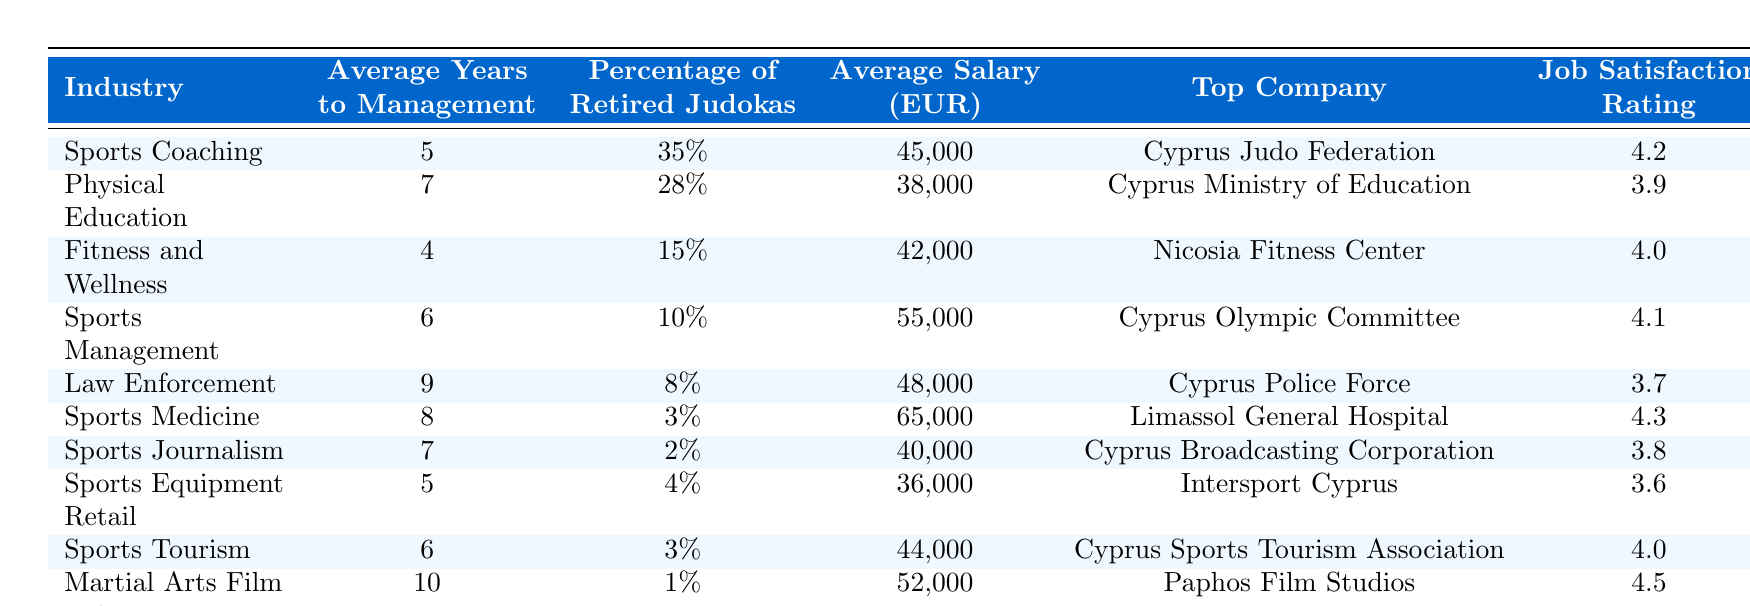What is the average salary in the Sports Medicine industry? According to the table, the average salary in the Sports Medicine industry is listed as 65,000 EUR.
Answer: 65,000 EUR What percentage of retired judokas work in Sports Management? The table states that 10% of retired judokas work in the Sports Management industry.
Answer: 10% Which industry has the highest job satisfaction rating, and what is that rating? Looking at the table, the Sports Medicine industry has the highest job satisfaction rating at 4.3.
Answer: Sports Medicine, 4.3 What is the difference in average salary between Sports Coaching and Sports Equipment Retail? The average salary for Sports Coaching is 45,000 EUR and for Sports Equipment Retail is 36,000 EUR. Thus, the difference is 45,000 - 36,000 = 9,000 EUR.
Answer: 9,000 EUR In which industry are retired judokas most likely to become managers the fastest? The average years to management in the Sports Coaching industry is the lowest, at 5 years, indicating that retired judokas are likely to become managers fastest in this industry.
Answer: Sports Coaching Is there any industry where the percentage of retired judokas is above 30%? Yes, in the Sports Coaching industry, the percentage of retired judokas is 35%, which is above 30%.
Answer: Yes What is the average years to management for all the industries combined? To find the average, I sum the average years to management from all industries: (5 + 7 + 4 + 6 + 9 + 8 + 7 + 5 + 6 + 10) = 57 years. Then, divide by the number of industries (10): 57 / 10 = 5.7 years.
Answer: 5.7 years Which industry has the lowest percentage of retired judokas? According to the table, the Sports Journalism industry has the lowest percentage of retired judokas at 2%.
Answer: 2% What is the average salary of industries with a job satisfaction rating of 4.0 or higher? The eligible industries are Sports Coaching (45,000 EUR), Fitness and Wellness (42,000 EUR), Sports Management (55,000 EUR), Sports Medicine (65,000 EUR), Sports Tourism (44,000 EUR), and Martial Arts Film Industry (52,000 EUR). Their average is (45,000 + 42,000 + 55,000 + 65,000 + 44,000 + 52,000) / 6 = 50,333.33 EUR.
Answer: 50,333.33 EUR How long does it take to reach management in the Fitness and Wellness industry compared to Law Enforcement? The table shows that it takes 4 years in Fitness and Wellness and 9 years in Law Enforcement, meaning it takes 5 years longer in Law Enforcement.
Answer: 5 years longer In which industry is the top company the Cyprus Police Force? The top company is the Cyprus Police Force in the Law Enforcement industry, as outlined in the table.
Answer: Law Enforcement 